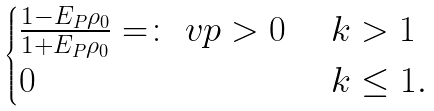Convert formula to latex. <formula><loc_0><loc_0><loc_500><loc_500>\begin{cases} \frac { 1 - E _ { P } \rho _ { 0 } } { 1 + E _ { P } \rho _ { 0 } } = \colon \ v p > 0 & \ k > 1 \\ 0 & \ k \leq 1 . \end{cases}</formula> 